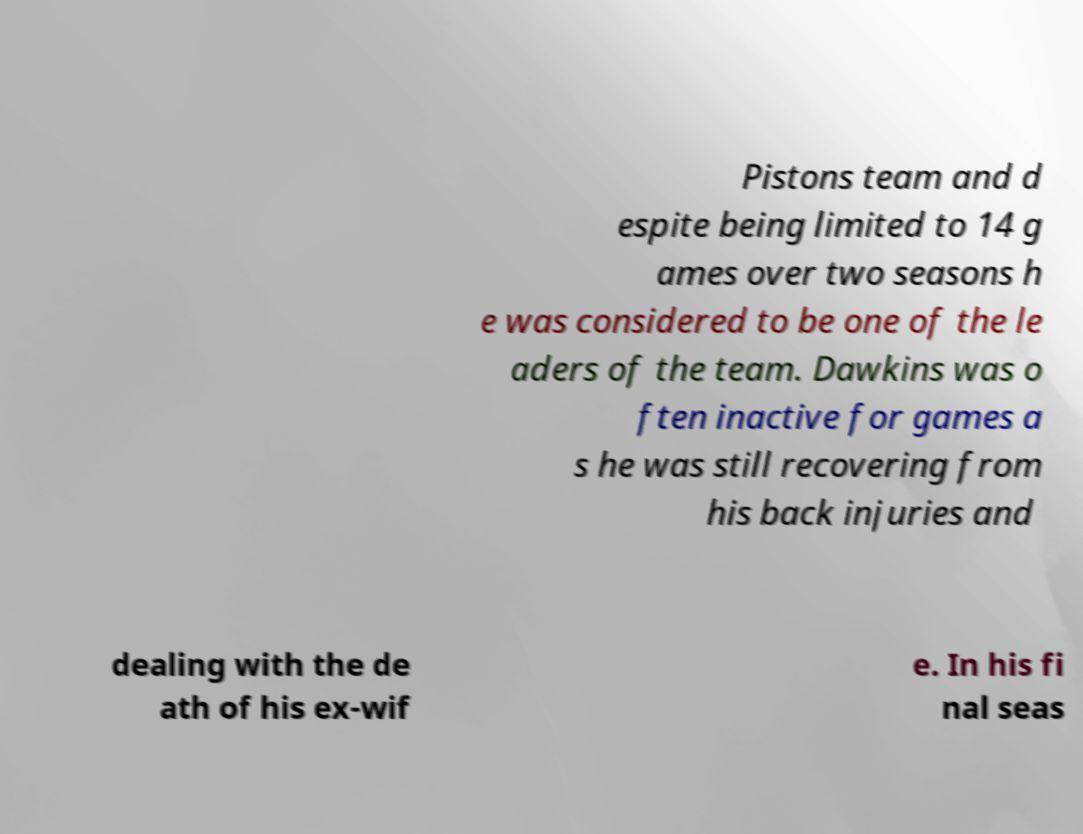Can you accurately transcribe the text from the provided image for me? Pistons team and d espite being limited to 14 g ames over two seasons h e was considered to be one of the le aders of the team. Dawkins was o ften inactive for games a s he was still recovering from his back injuries and dealing with the de ath of his ex-wif e. In his fi nal seas 